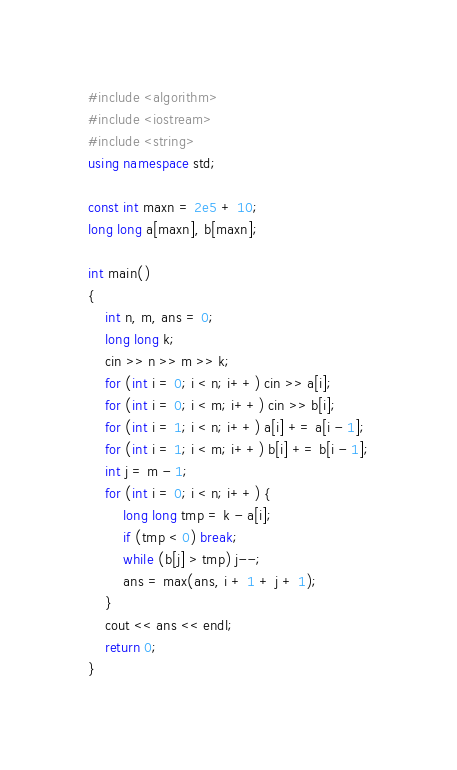<code> <loc_0><loc_0><loc_500><loc_500><_C++_>#include <algorithm>
#include <iostream>
#include <string>
using namespace std;

const int maxn = 2e5 + 10;
long long a[maxn], b[maxn];

int main()
{
    int n, m, ans = 0;
    long long k;
    cin >> n >> m >> k;
    for (int i = 0; i < n; i++) cin >> a[i];
    for (int i = 0; i < m; i++) cin >> b[i];
    for (int i = 1; i < n; i++) a[i] += a[i - 1];
    for (int i = 1; i < m; i++) b[i] += b[i - 1];
    int j = m - 1;
    for (int i = 0; i < n; i++) {
        long long tmp = k - a[i];
        if (tmp < 0) break;
        while (b[j] > tmp) j--;
        ans = max(ans, i + 1 + j + 1);
    }
    cout << ans << endl;
    return 0;
}</code> 